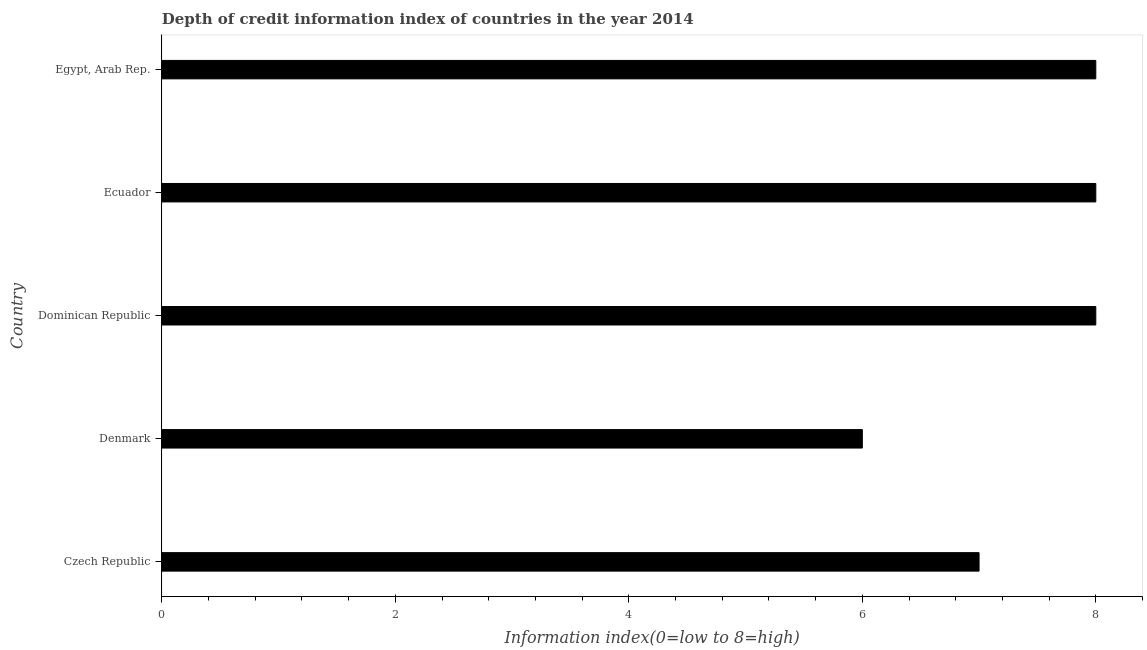Does the graph contain grids?
Keep it short and to the point. No. What is the title of the graph?
Offer a very short reply. Depth of credit information index of countries in the year 2014. What is the label or title of the X-axis?
Provide a succinct answer. Information index(0=low to 8=high). What is the label or title of the Y-axis?
Provide a short and direct response. Country. What is the depth of credit information index in Ecuador?
Give a very brief answer. 8. Across all countries, what is the maximum depth of credit information index?
Offer a terse response. 8. Across all countries, what is the minimum depth of credit information index?
Your answer should be compact. 6. In which country was the depth of credit information index maximum?
Give a very brief answer. Dominican Republic. What is the average depth of credit information index per country?
Give a very brief answer. 7.4. What is the median depth of credit information index?
Your answer should be very brief. 8. Is the depth of credit information index in Dominican Republic less than that in Ecuador?
Your answer should be very brief. No. Is the difference between the depth of credit information index in Ecuador and Egypt, Arab Rep. greater than the difference between any two countries?
Your answer should be very brief. No. What is the difference between the highest and the second highest depth of credit information index?
Offer a very short reply. 0. Is the sum of the depth of credit information index in Czech Republic and Denmark greater than the maximum depth of credit information index across all countries?
Offer a very short reply. Yes. In how many countries, is the depth of credit information index greater than the average depth of credit information index taken over all countries?
Ensure brevity in your answer.  3. How many bars are there?
Your answer should be compact. 5. Are all the bars in the graph horizontal?
Provide a short and direct response. Yes. What is the Information index(0=low to 8=high) in Ecuador?
Offer a very short reply. 8. What is the difference between the Information index(0=low to 8=high) in Czech Republic and Egypt, Arab Rep.?
Offer a terse response. -1. What is the difference between the Information index(0=low to 8=high) in Denmark and Egypt, Arab Rep.?
Your answer should be compact. -2. What is the difference between the Information index(0=low to 8=high) in Dominican Republic and Ecuador?
Ensure brevity in your answer.  0. What is the difference between the Information index(0=low to 8=high) in Dominican Republic and Egypt, Arab Rep.?
Offer a very short reply. 0. What is the difference between the Information index(0=low to 8=high) in Ecuador and Egypt, Arab Rep.?
Keep it short and to the point. 0. What is the ratio of the Information index(0=low to 8=high) in Czech Republic to that in Denmark?
Make the answer very short. 1.17. What is the ratio of the Information index(0=low to 8=high) in Czech Republic to that in Dominican Republic?
Give a very brief answer. 0.88. What is the ratio of the Information index(0=low to 8=high) in Denmark to that in Ecuador?
Your response must be concise. 0.75. What is the ratio of the Information index(0=low to 8=high) in Dominican Republic to that in Ecuador?
Make the answer very short. 1. What is the ratio of the Information index(0=low to 8=high) in Dominican Republic to that in Egypt, Arab Rep.?
Provide a short and direct response. 1. What is the ratio of the Information index(0=low to 8=high) in Ecuador to that in Egypt, Arab Rep.?
Your response must be concise. 1. 